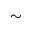<formula> <loc_0><loc_0><loc_500><loc_500>\sim</formula> 